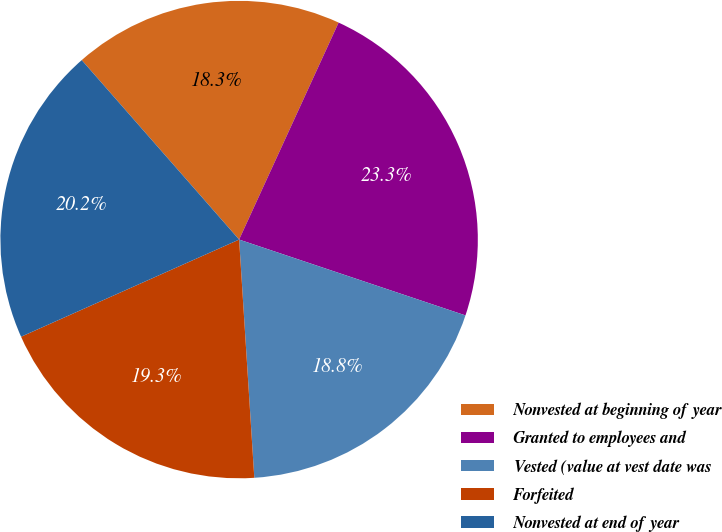Convert chart to OTSL. <chart><loc_0><loc_0><loc_500><loc_500><pie_chart><fcel>Nonvested at beginning of year<fcel>Granted to employees and<fcel>Vested (value at vest date was<fcel>Forfeited<fcel>Nonvested at end of year<nl><fcel>18.3%<fcel>23.3%<fcel>18.84%<fcel>19.34%<fcel>20.21%<nl></chart> 